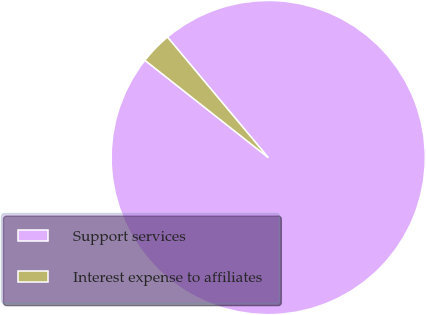<chart> <loc_0><loc_0><loc_500><loc_500><pie_chart><fcel>Support services<fcel>Interest expense to affiliates<nl><fcel>96.72%<fcel>3.28%<nl></chart> 